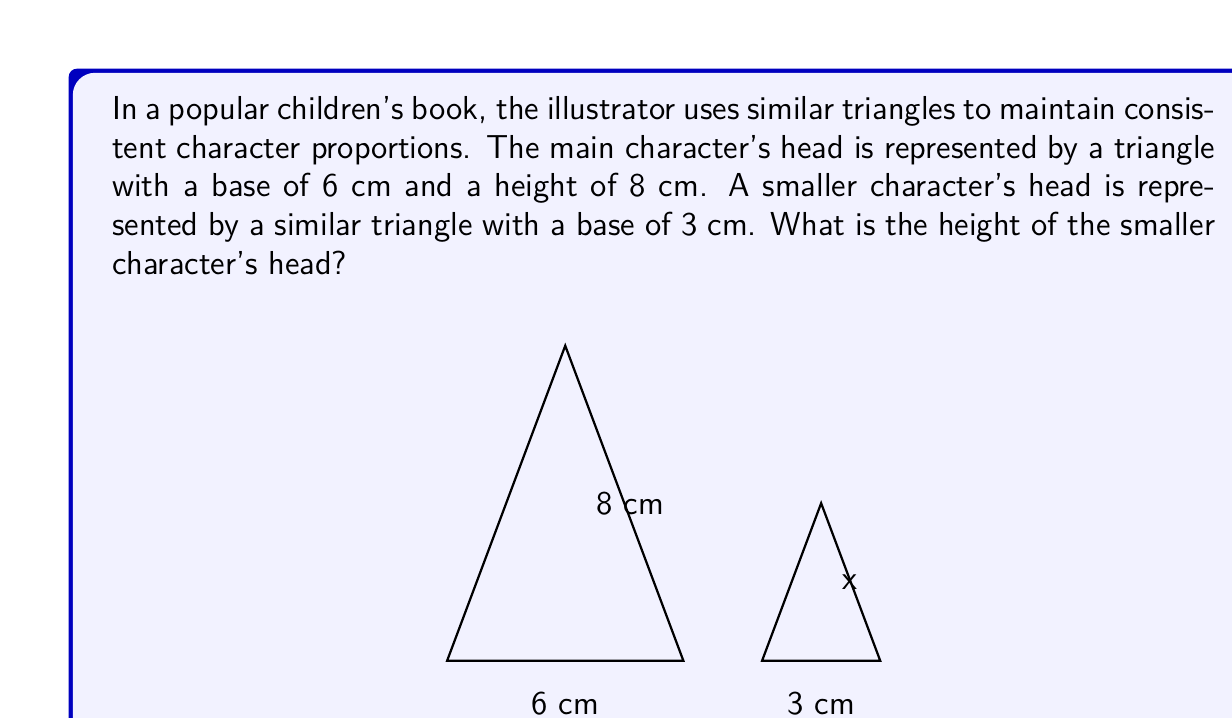Give your solution to this math problem. Let's solve this step-by-step using the properties of similar triangles:

1) In similar triangles, the ratio of corresponding sides is constant. Let's call this ratio $r$.

2) We can find $r$ using the bases of the triangles:
   $r = \frac{\text{smaller base}}{\text{larger base}} = \frac{3}{6} = \frac{1}{2}$

3) This ratio $r$ will be the same for all corresponding sides, including the heights.

4) Let $x$ be the height of the smaller triangle. We can set up the following proportion:
   $\frac{x}{8} = \frac{1}{2}$

5) To solve for $x$, we can cross-multiply:
   $x \cdot 2 = 8 \cdot 1$
   $2x = 8$

6) Dividing both sides by 2:
   $x = 4$

Therefore, the height of the smaller character's head is 4 cm.
Answer: 4 cm 